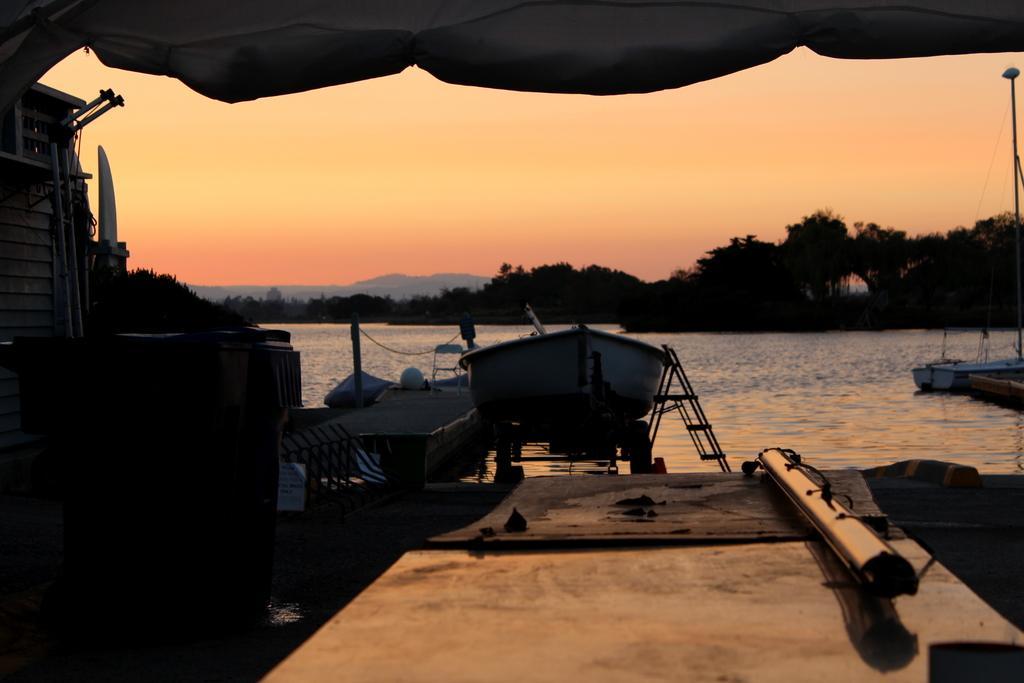In one or two sentences, can you explain what this image depicts? In this picture we can see a boat on the water and on the left side of the boat there is a chair on the path and other things. Behind the boat there are trees, hills and a sky. 